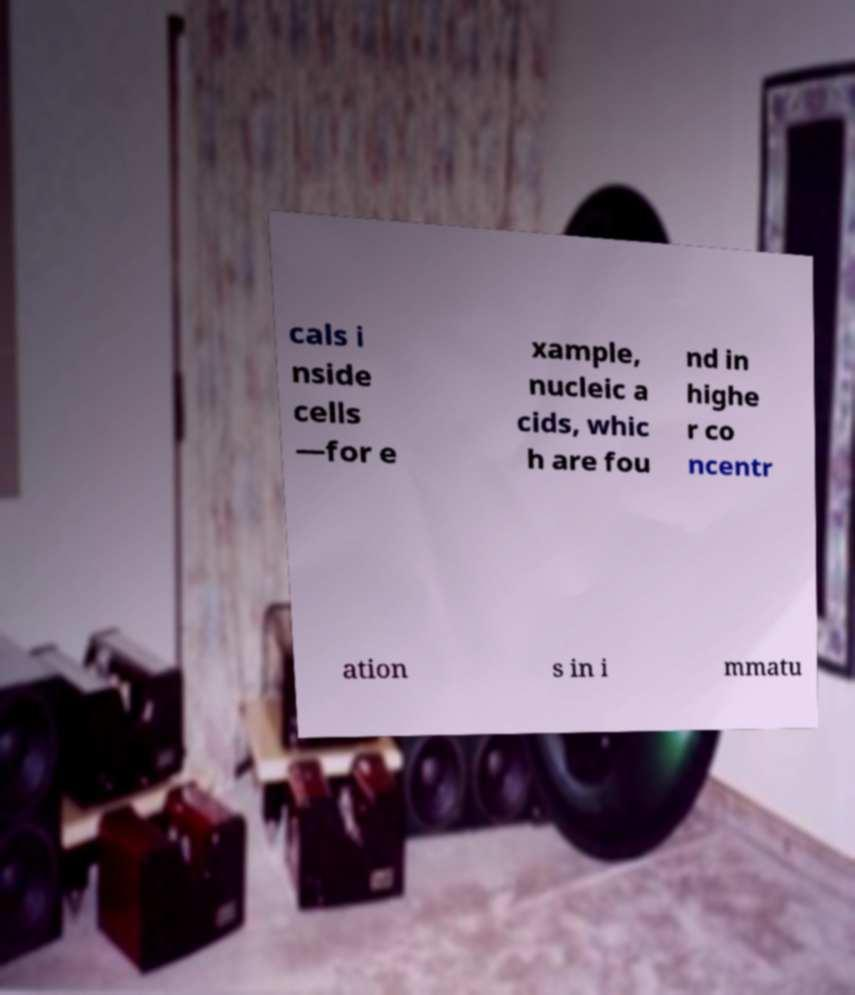What messages or text are displayed in this image? I need them in a readable, typed format. cals i nside cells —for e xample, nucleic a cids, whic h are fou nd in highe r co ncentr ation s in i mmatu 